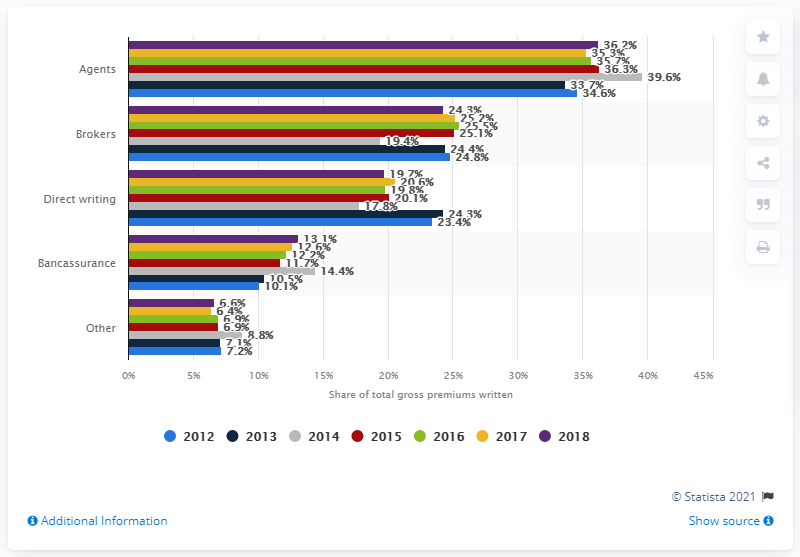Indicate a few pertinent items in this graphic. In 2018, agents wrote 36.3% of non-life insurance premiums. 